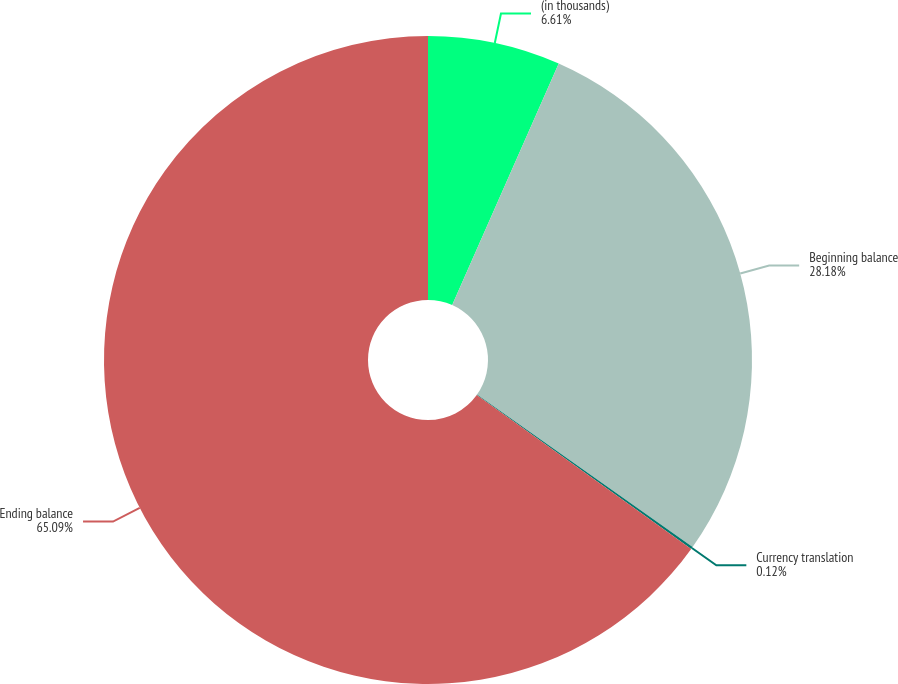Convert chart to OTSL. <chart><loc_0><loc_0><loc_500><loc_500><pie_chart><fcel>(in thousands)<fcel>Beginning balance<fcel>Currency translation<fcel>Ending balance<nl><fcel>6.61%<fcel>28.18%<fcel>0.12%<fcel>65.09%<nl></chart> 